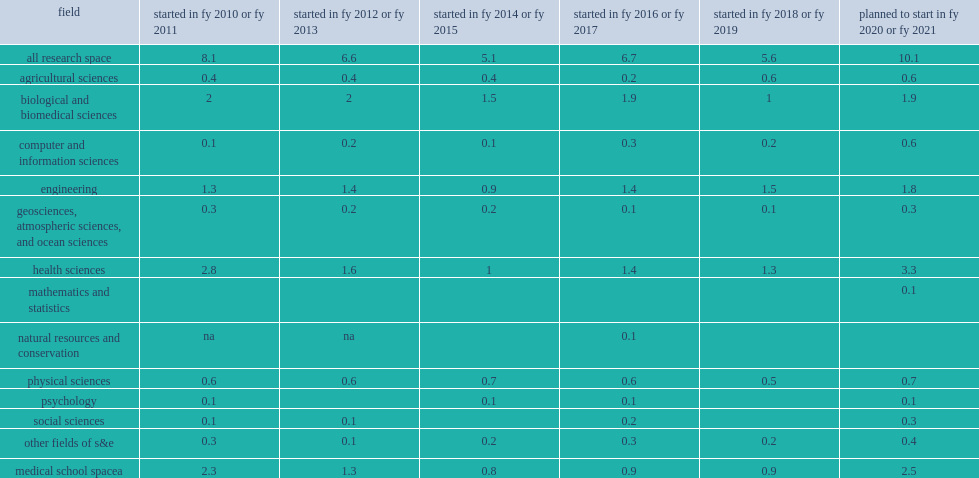How many million nasf did academic institutions break ground of new s&e research space construction projects in fys 2018-19? 5.6. 